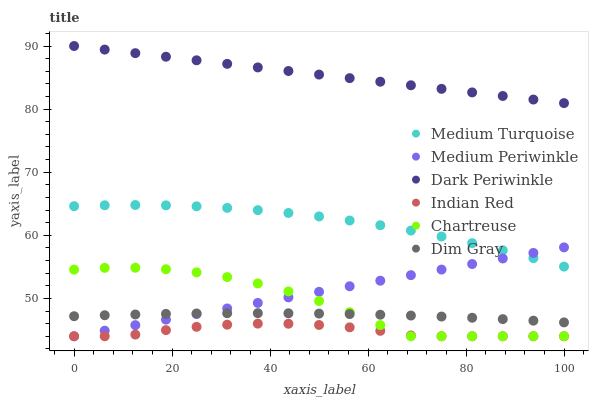Does Indian Red have the minimum area under the curve?
Answer yes or no. Yes. Does Dark Periwinkle have the maximum area under the curve?
Answer yes or no. Yes. Does Medium Turquoise have the minimum area under the curve?
Answer yes or no. No. Does Medium Turquoise have the maximum area under the curve?
Answer yes or no. No. Is Medium Periwinkle the smoothest?
Answer yes or no. Yes. Is Chartreuse the roughest?
Answer yes or no. Yes. Is Medium Turquoise the smoothest?
Answer yes or no. No. Is Medium Turquoise the roughest?
Answer yes or no. No. Does Medium Periwinkle have the lowest value?
Answer yes or no. Yes. Does Medium Turquoise have the lowest value?
Answer yes or no. No. Does Dark Periwinkle have the highest value?
Answer yes or no. Yes. Does Medium Turquoise have the highest value?
Answer yes or no. No. Is Indian Red less than Dark Periwinkle?
Answer yes or no. Yes. Is Dim Gray greater than Indian Red?
Answer yes or no. Yes. Does Medium Periwinkle intersect Dim Gray?
Answer yes or no. Yes. Is Medium Periwinkle less than Dim Gray?
Answer yes or no. No. Is Medium Periwinkle greater than Dim Gray?
Answer yes or no. No. Does Indian Red intersect Dark Periwinkle?
Answer yes or no. No. 